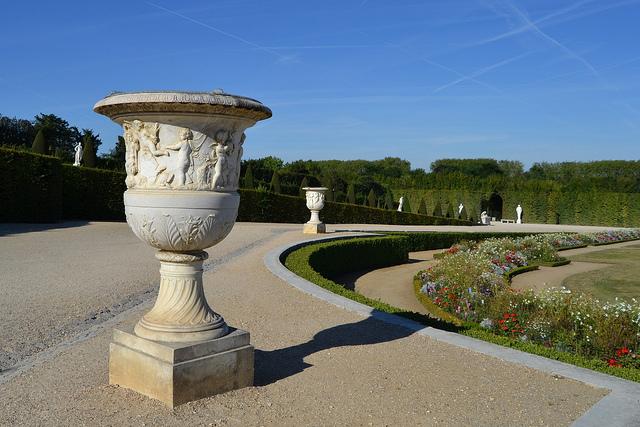What are the vases sitting on?
Concise answer only. Ground. What kind of decorations appear on the closest flower pot?
Short answer required. Cherubs. What is the object is located to the right?
Concise answer only. Statue. Is it day or night?
Write a very short answer. Day. 